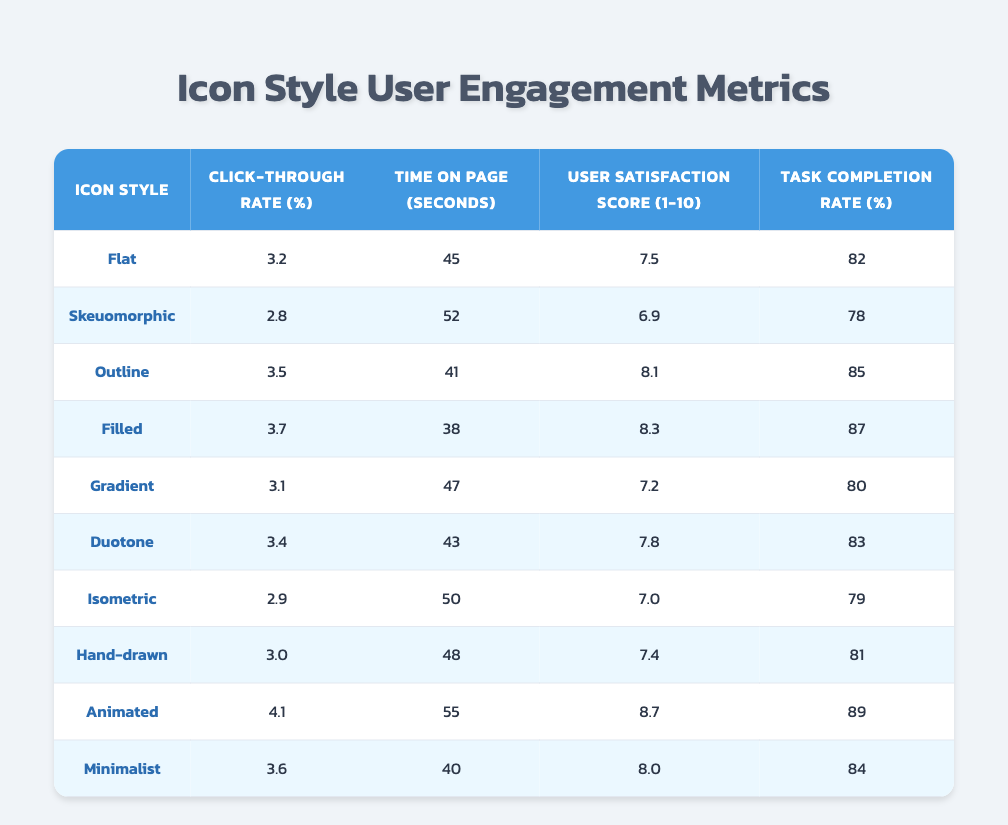What is the highest click-through rate among the icon styles? The click-through rates in the table are: Flat (3.2), Skeuomorphic (2.8), Outline (3.5), Filled (3.7), Gradient (3.1), Duotone (3.4), Isometric (2.9), Hand-drawn (3.0), Animated (4.1), and Minimalist (3.6). The highest value is 4.1, which corresponds to the Animated icon style.
Answer: 4.1 Which icon style has the lowest user satisfaction score? The user satisfaction scores are: Flat (7.5), Skeuomorphic (6.9), Outline (8.1), Filled (8.3), Gradient (7.2), Duotone (7.8), Isometric (7.0), Hand-drawn (7.4), Animated (8.7), and Minimalist (8.0). The lowest score is 6.9, which belongs to the Skeuomorphic icon style.
Answer: Skeuomorphic What is the average time on page for all icon styles? To find the average, sum the time on page values: (45 + 52 + 41 + 38 + 47 + 43 + 50 + 48 + 55 + 40) = 419 seconds. There are 10 styles, so the average is 419 / 10 = 41.9 seconds.
Answer: 41.9 Is the task completion rate for Filled style greater than 85%? The task completion rate for the Filled icon style is 87%. Since 87% is greater than 85%, the statement is true.
Answer: Yes Which icon styles have a click-through rate higher than 3.5%? The click-through rates above 3.5% are: Outline (3.5), Filled (3.7), Gradient (3.1), Duotone (3.4), Isometric (2.9), Hand-drawn (3.0), Animated (4.1), and Minimalist (3.6). The styles that exceed 3.5% are Filled (3.7), Animated (4.1), and Minimalist (3.6).
Answer: Filled, Animated, Minimalist What is the difference between the maximum and minimum time on page? The maximum time on page is 55 seconds (Animated) and the minimum time is 38 seconds (Filled). The difference is 55 - 38 = 17 seconds.
Answer: 17 Do all icon styles have a user satisfaction score of 7 or higher? The user satisfaction scores are: Flat (7.5), Skeuomorphic (6.9), Outline (8.1), Filled (8.3), Gradient (7.2), Duotone (7.8), Isometric (7.0), Hand-drawn (7.4), Animated (8.7), and Minimalist (8.0). Since Skeuomorphic has a score of 6.9, not all scores are 7 or higher.
Answer: No What is the task completion rate of the icon style with the second highest click-through rate? The click-through rates in descending order are: Animated (4.1), Filled (3.7), Outline (3.5), Minimalist (3.6), Duotone (3.4), Flat (3.2), Gradient (3.1), Hand-drawn (3.0), Isometric (2.9), Skeuomorphic (2.8). The second highest is Filled (3.7), with a task completion rate of 87%.
Answer: 87 